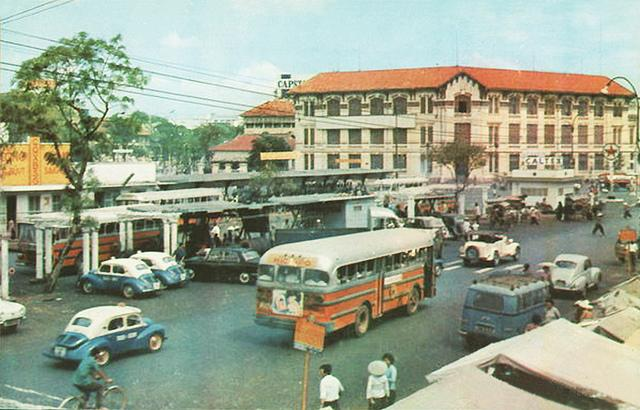What is the name of the gas station with the red star?

Choices:
A) shell
B) sinclair
C) texaco
D) caltex caltex 